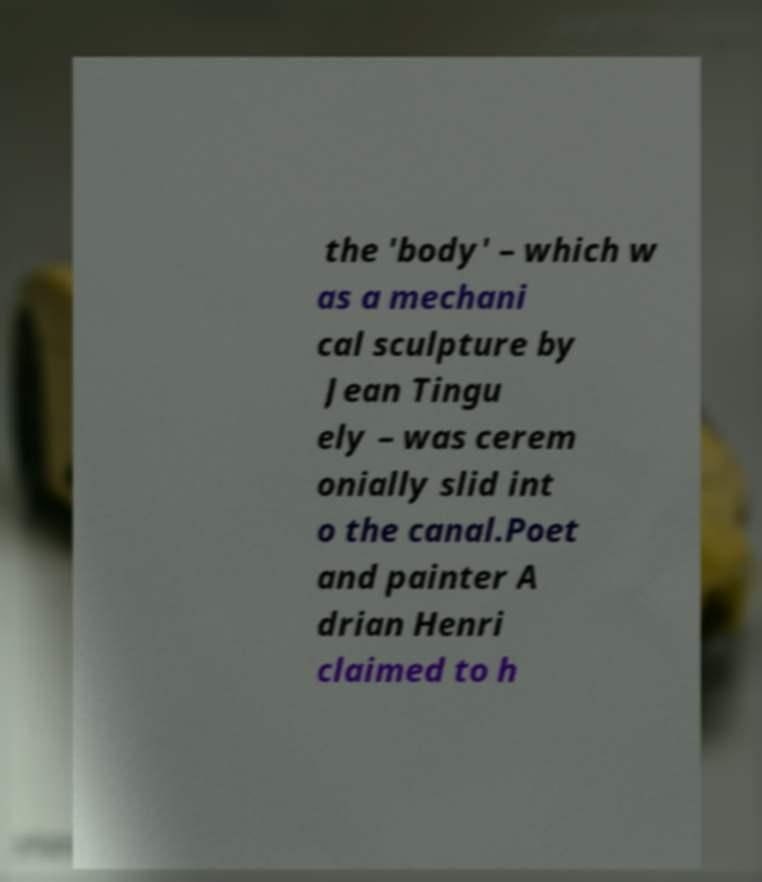Can you read and provide the text displayed in the image?This photo seems to have some interesting text. Can you extract and type it out for me? the 'body' – which w as a mechani cal sculpture by Jean Tingu ely – was cerem onially slid int o the canal.Poet and painter A drian Henri claimed to h 